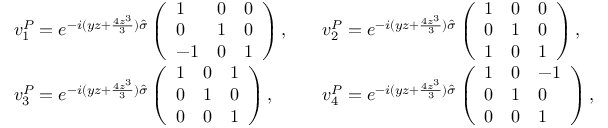<formula> <loc_0><loc_0><loc_500><loc_500>\begin{array} { r l r l } & { v _ { 1 } ^ { P } = e ^ { - i ( y z + \frac { 4 z ^ { 3 } } { 3 } ) \hat { \sigma } } \left ( \begin{array} { l l l } { 1 } & { 0 } & { 0 } \\ { 0 } & { 1 } & { 0 } \\ { - 1 } & { 0 } & { 1 } \end{array} \right ) , } & & { v _ { 2 } ^ { P } = e ^ { - i ( y z + \frac { 4 z ^ { 3 } } { 3 } ) \hat { \sigma } } \left ( \begin{array} { l l l } { 1 } & { 0 } & { 0 } \\ { 0 } & { 1 } & { 0 } \\ { 1 } & { 0 } & { 1 } \end{array} \right ) , } \\ & { v _ { 3 } ^ { P } = e ^ { - i ( y z + \frac { 4 z ^ { 3 } } { 3 } ) \hat { \sigma } } \left ( \begin{array} { l l l } { 1 } & { 0 } & { 1 } \\ { 0 } & { 1 } & { 0 } \\ { 0 } & { 0 } & { 1 } \end{array} \right ) , } & & { v _ { 4 } ^ { P } = e ^ { - i ( y z + \frac { 4 z ^ { 3 } } { 3 } ) \hat { \sigma } } \left ( \begin{array} { l l l } { 1 } & { 0 } & { - 1 } \\ { 0 } & { 1 } & { 0 } \\ { 0 } & { 0 } & { 1 } \end{array} \right ) , } \end{array}</formula> 